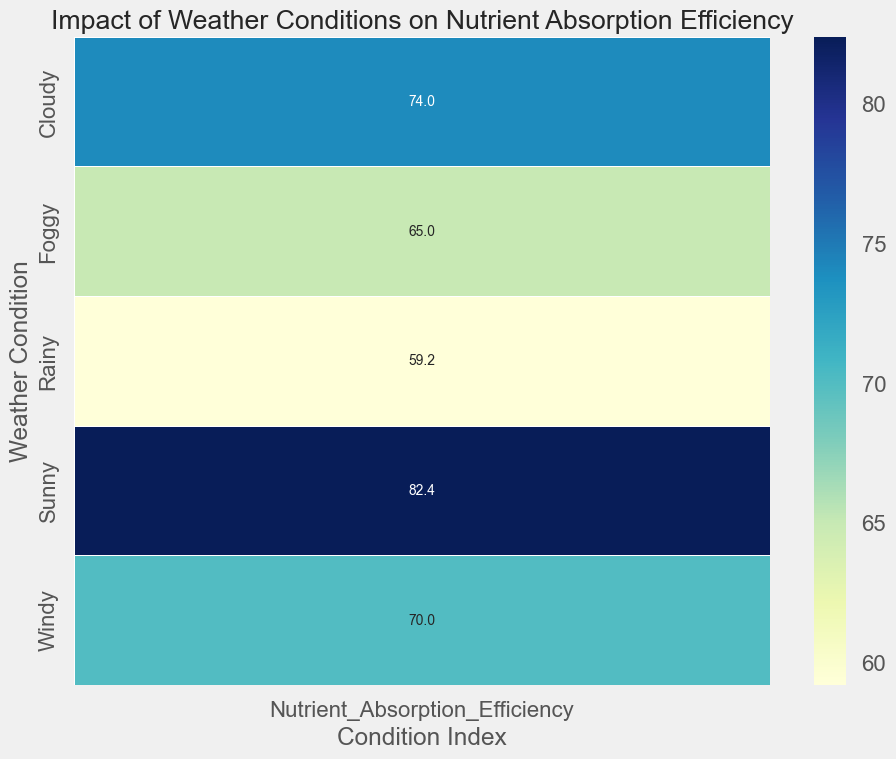Which weather condition has the highest average nutrient absorption efficiency? Look at the heatmap and identify the weather condition with the darkest color indicating the highest efficiency number.
Answer: Sunny Which weather condition has the lowest average nutrient absorption efficiency? Look at the heatmap and identify the weather condition with the lightest color indicating the lowest efficiency number.
Answer: Rainy What is the average nutrient absorption efficiency for Foggy weather conditions? Locate the cell corresponding to Foggy weather on the heatmap and read the number.
Answer: 65.0 How much higher is the nutrient absorption efficiency in Sunny conditions compared to Cloudy conditions? Find the average efficiency for Sunny and Cloudy weather from the heatmap. Subtract the Cloudy value from the Sunny value (82.0 - 74.0).
Answer: 8.0 Does Cloudy weather have a higher or lower average nutrient absorption efficiency compared to Windy weather? Compare the values for Cloudy and Windy on the heatmap.
Answer: Lower Which weather condition has an average nutrient absorption efficiency closer to 70: Foggy or Windy? Compare the average efficiency values for Foggy (65.0) and Windy (70.0) to 70 and see which is closest.
Answer: Windy How many different weather conditions are shown in the heatmap? Count the rows on the heatmap corresponding to different weather conditions.
Answer: 5 What is the difference in the average nutrient absorption efficiency between Sunny and Rainy weather conditions? Subtract the average efficiency value for Rainy from that for Sunny (82.0 - 59.0).
Answer: 23.0 